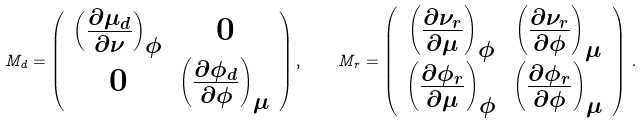<formula> <loc_0><loc_0><loc_500><loc_500>M _ { d } = \left ( \begin{array} { c c } \left ( \frac { \partial \mu _ { d } } { \partial \nu } \right ) _ { \phi } & 0 \\ 0 & \left ( \frac { \partial \phi _ { d } } { \partial \phi } \right ) _ { \mu } \end{array} \right ) , \quad M _ { r } = \left ( \begin{array} { c c } \left ( \frac { \partial \nu _ { r } } { \partial \mu } \right ) _ { \phi } & \left ( \frac { \partial \nu _ { r } } { \partial \phi } \right ) _ { \mu } \\ \left ( \frac { \partial \phi _ { r } } { \partial \mu } \right ) _ { \phi } & \left ( \frac { \partial \phi _ { r } } { \partial \phi } \right ) _ { \mu } \end{array} \right ) \, .</formula> 